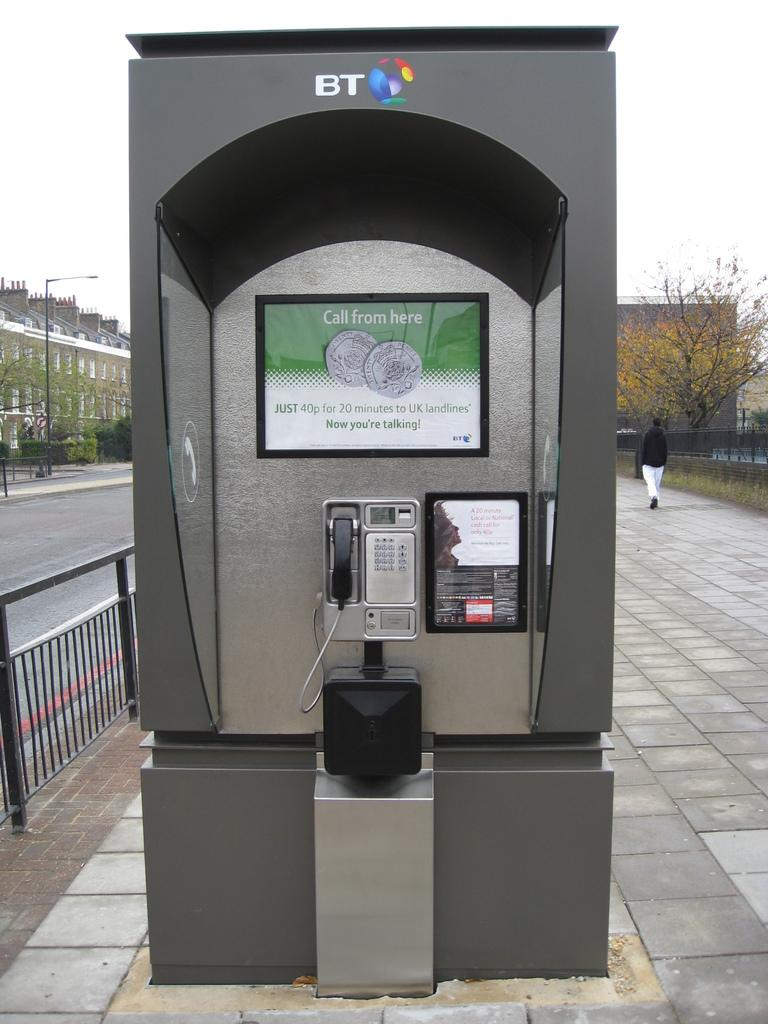<image>
Relay a brief, clear account of the picture shown. The phone has a BT sticker on top of it 